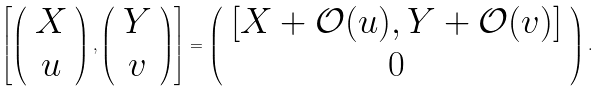Convert formula to latex. <formula><loc_0><loc_0><loc_500><loc_500>\left [ \left ( \begin{array} { c } X \\ u \end{array} \right ) , \left ( \begin{array} { c } Y \\ v \end{array} \right ) \right ] = \left ( \begin{array} { c } [ X + { \mathcal { O } } ( u ) , Y + { \mathcal { O } } ( v ) ] \\ 0 \end{array} \right ) .</formula> 